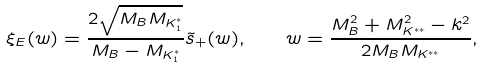<formula> <loc_0><loc_0><loc_500><loc_500>\xi _ { E } ( w ) = \frac { 2 \sqrt { M _ { B } M _ { K _ { 1 } ^ { * } } } } { M _ { B } - M _ { K _ { 1 } ^ { * } } } \tilde { s } _ { + } ( w ) , \quad w = \frac { M ^ { 2 } _ { B } + M ^ { 2 } _ { K ^ { * * } } - k ^ { 2 } } { 2 M _ { B } M _ { K ^ { * * } } } ,</formula> 